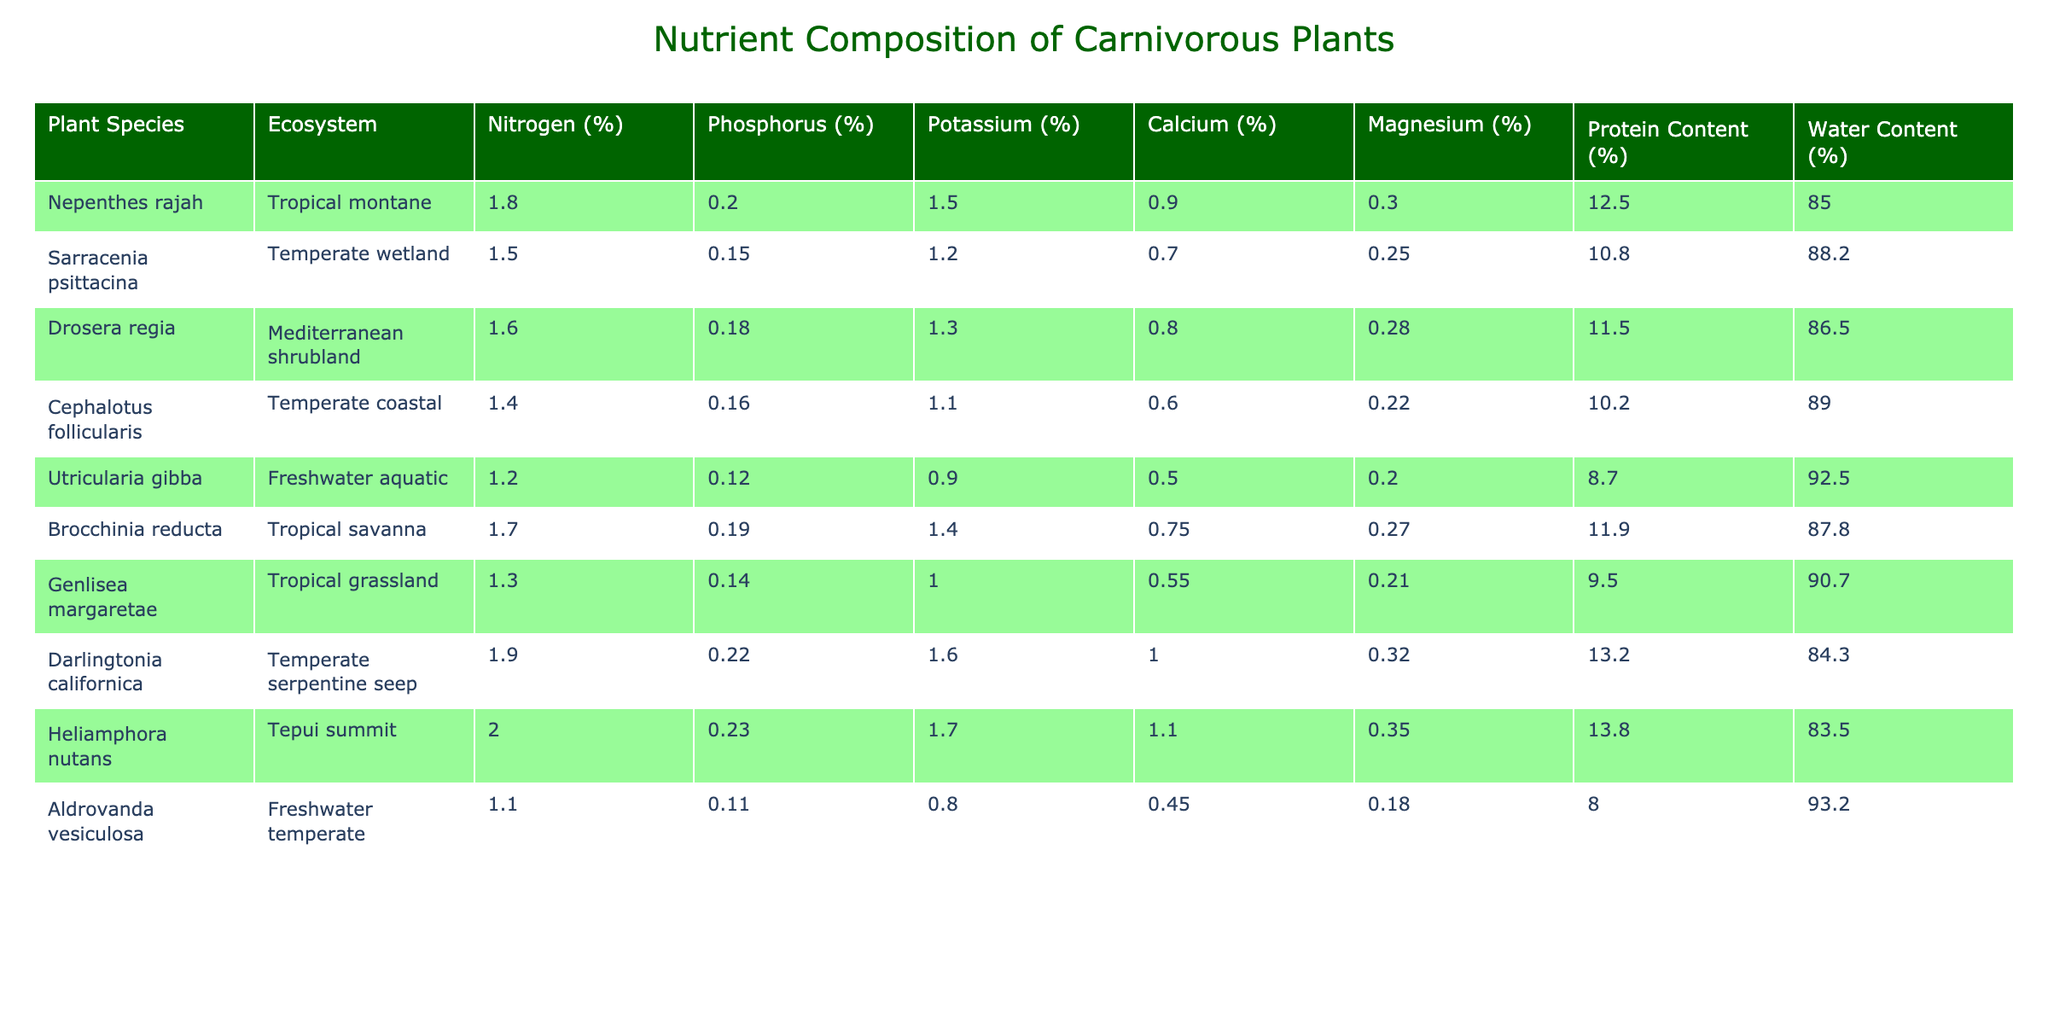What is the nitrogen percentage in Nepenthes rajah? The table lists Nepenthes rajah under the Tropical montane ecosystem, with its nitrogen percentage clearly stated as 1.8%.
Answer: 1.8% Which plant species has the highest protein content? By looking at the protein content values in the table, Heliamphora nutans has the highest value at 13.8%.
Answer: Heliamphora nutans Is the water content in Utricularia gibba higher than in Cephalotus follicularis? The table shows the water content for Utricularia gibba as 92.5% and for Cephalotus follicularis as 89%. Since 92.5% is greater than 89%, the statement is true.
Answer: Yes What is the average phosphorus content of the plants in tropical ecosystems? The phosphorus percentages for tropical species are Nepenthes rajah (0.2%), Brocchinia reducta (0.19%), and Heliamphora nutans (0.23%). To find the average, we sum these values: 0.2 + 0.19 + 0.23 = 0.62. We then divide by 3 (the number of species), resulting in an average of 0.62 / 3 = 0.20667%, which we can round to 0.21%.
Answer: 0.21% Does Darlingtonia californica contain more calcium than Utricularia gibba? The table lists Darlingtonia californica with a calcium content of 1.0% and Utricularia gibba with 0.5%. Since 1.0% is greater than 0.5%, the statement is true.
Answer: Yes What is the difference in potassium content between the plant with the highest and the lowest potassium percentage? The highest potassium value is for Darlingtonia californica at 1.6% and the lowest is for Aldrovanda vesiculosa at 0.8%. To find the difference, subtract 0.8 from 1.6, giving us 1.6 - 0.8 = 0.8%.
Answer: 0.8% Which ecosystem has the highest average protein content among the listed plants? To find the ecosystem with the highest average protein content, we examine the plants classified by ecosystem: Tropical montane (Nepenthes rajah 12.5%), Mediterranean shrubland (Drosera regia 11.5%), and others. The averages show that, for Tropical montane, the value is quite high. Listing all plants that belong to that ecosystem, Tropical montane leads with 12.5%, while in others, the averages drop significantly.
Answer: Tropical montane Is it true that all carnivorous plants listed have a water content above 80%? When checking the water content values of each plant, all percentages are above 80%, with the lowest at 83.5% for Heliamphora nutans. Therefore, the statement is true.
Answer: Yes 